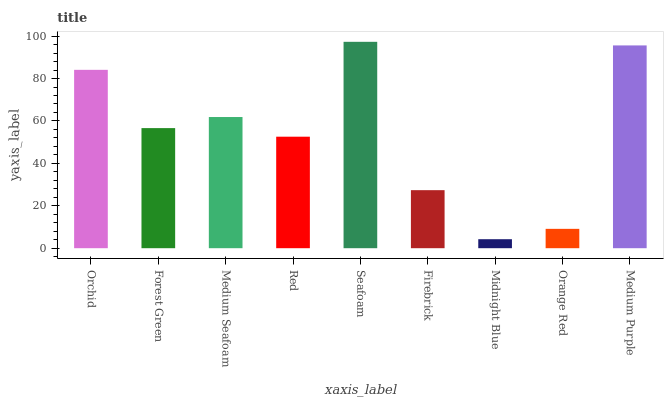Is Midnight Blue the minimum?
Answer yes or no. Yes. Is Seafoam the maximum?
Answer yes or no. Yes. Is Forest Green the minimum?
Answer yes or no. No. Is Forest Green the maximum?
Answer yes or no. No. Is Orchid greater than Forest Green?
Answer yes or no. Yes. Is Forest Green less than Orchid?
Answer yes or no. Yes. Is Forest Green greater than Orchid?
Answer yes or no. No. Is Orchid less than Forest Green?
Answer yes or no. No. Is Forest Green the high median?
Answer yes or no. Yes. Is Forest Green the low median?
Answer yes or no. Yes. Is Orange Red the high median?
Answer yes or no. No. Is Medium Seafoam the low median?
Answer yes or no. No. 